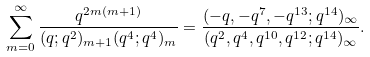Convert formula to latex. <formula><loc_0><loc_0><loc_500><loc_500>\sum _ { m = 0 } ^ { \infty } \frac { q ^ { 2 m ( m + 1 ) } } { ( q ; q ^ { 2 } ) _ { m + 1 } ( q ^ { 4 } ; q ^ { 4 } ) _ { m } } = \frac { ( - q , - q ^ { 7 } , - q ^ { 1 3 } ; q ^ { 1 4 } ) _ { \infty } } { ( q ^ { 2 } , q ^ { 4 } , q ^ { 1 0 } , q ^ { 1 2 } ; q ^ { 1 4 } ) _ { \infty } } .</formula> 